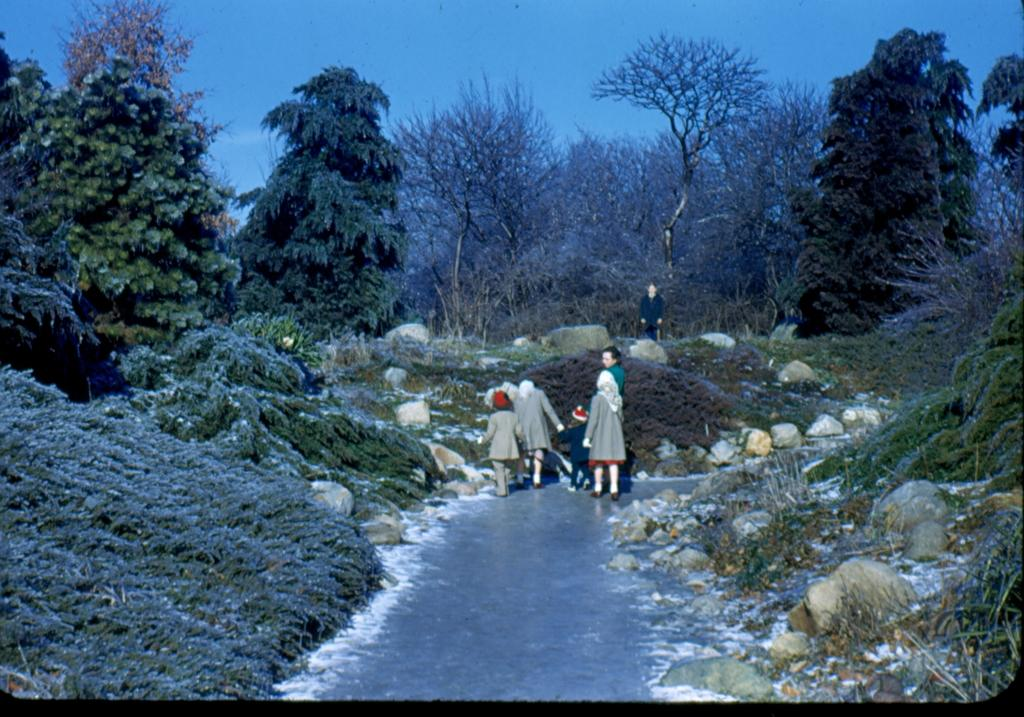What can be seen on the road in the image? There are persons on the road in the image. What type of natural elements are present in the image? There are plants, rocks, and trees in the image. What is visible in the background of the image? The sky is visible in the background of the image. Can you tell me how many robins are perched on the trees in the image? There are no robins present in the image; it features persons on the road, plants, rocks, trees, and a visible sky. What type of event is taking place in the image? The image does not depict a specific event; it simply shows persons on the road, plants, rocks, trees, and a visible sky. 